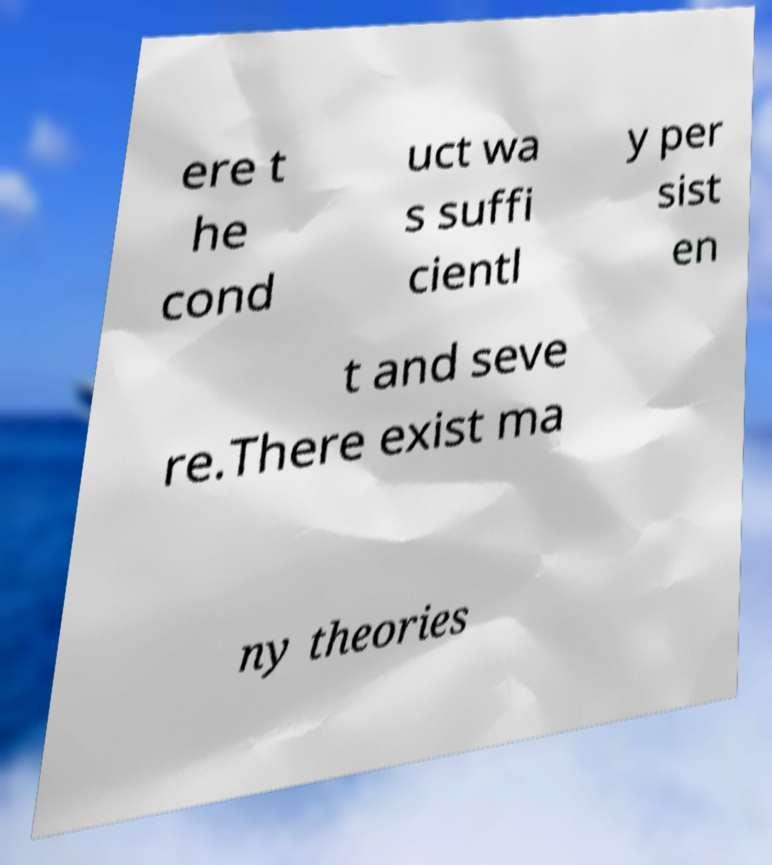Could you assist in decoding the text presented in this image and type it out clearly? ere t he cond uct wa s suffi cientl y per sist en t and seve re.There exist ma ny theories 